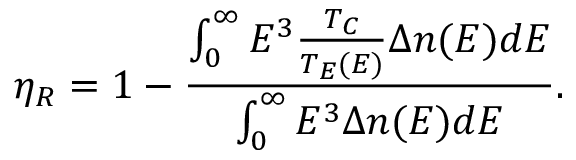Convert formula to latex. <formula><loc_0><loc_0><loc_500><loc_500>\eta _ { R } = 1 - \frac { \int _ { 0 } ^ { \infty } E ^ { 3 } \frac { T _ { C } } { T _ { E } ( E ) } \Delta n ( E ) d E } { \int _ { 0 } ^ { \infty } E ^ { 3 } \Delta n ( E ) d E } .</formula> 